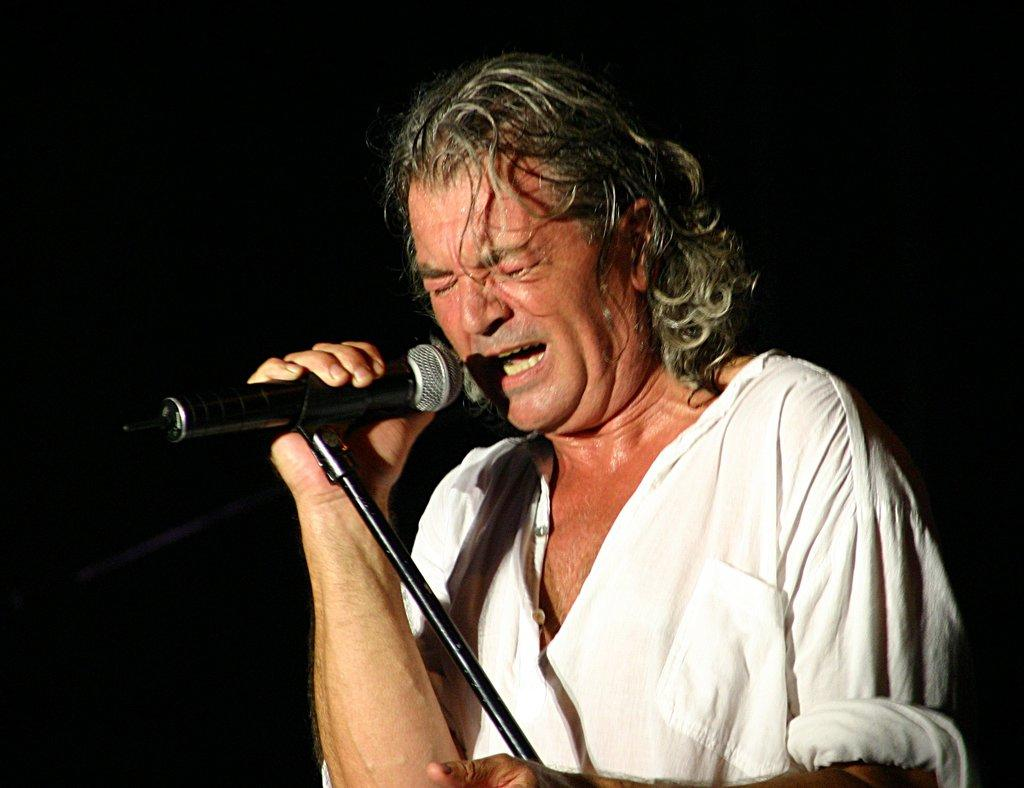What is the main subject of the image? The main subject of the image is a man. What is the man doing in the image? The man is singing in the image. What object is in front of the man? There is a mic in front of the man. What type of riddle can be seen written on the egg in the image? There is no egg or riddle present in the image. What type of camera is the man using to record his performance in the image? There is no camera visible in the image; it only shows the man singing with a mic in front of him. 